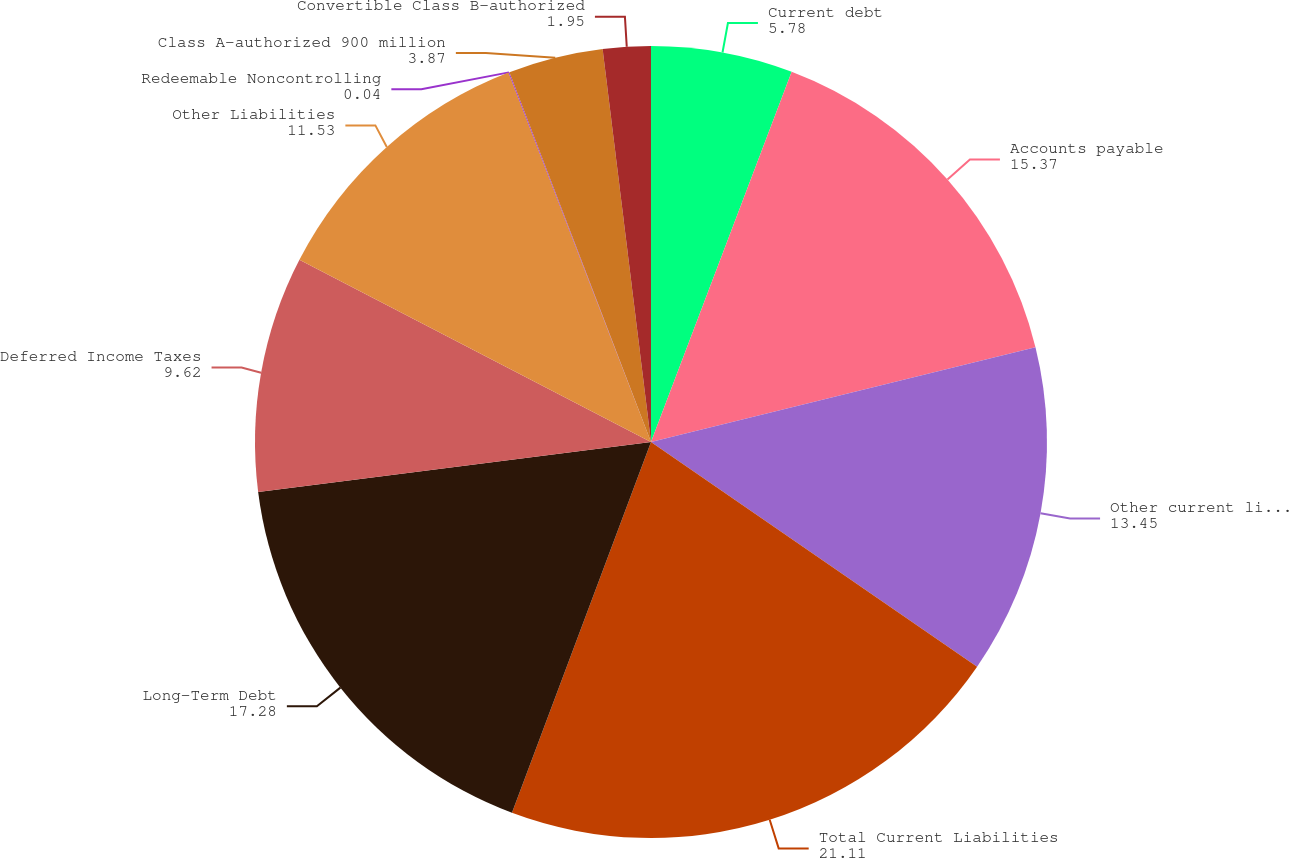Convert chart to OTSL. <chart><loc_0><loc_0><loc_500><loc_500><pie_chart><fcel>Current debt<fcel>Accounts payable<fcel>Other current liabilities<fcel>Total Current Liabilities<fcel>Long-Term Debt<fcel>Deferred Income Taxes<fcel>Other Liabilities<fcel>Redeemable Noncontrolling<fcel>Class A-authorized 900 million<fcel>Convertible Class B-authorized<nl><fcel>5.78%<fcel>15.37%<fcel>13.45%<fcel>21.11%<fcel>17.28%<fcel>9.62%<fcel>11.53%<fcel>0.04%<fcel>3.87%<fcel>1.95%<nl></chart> 